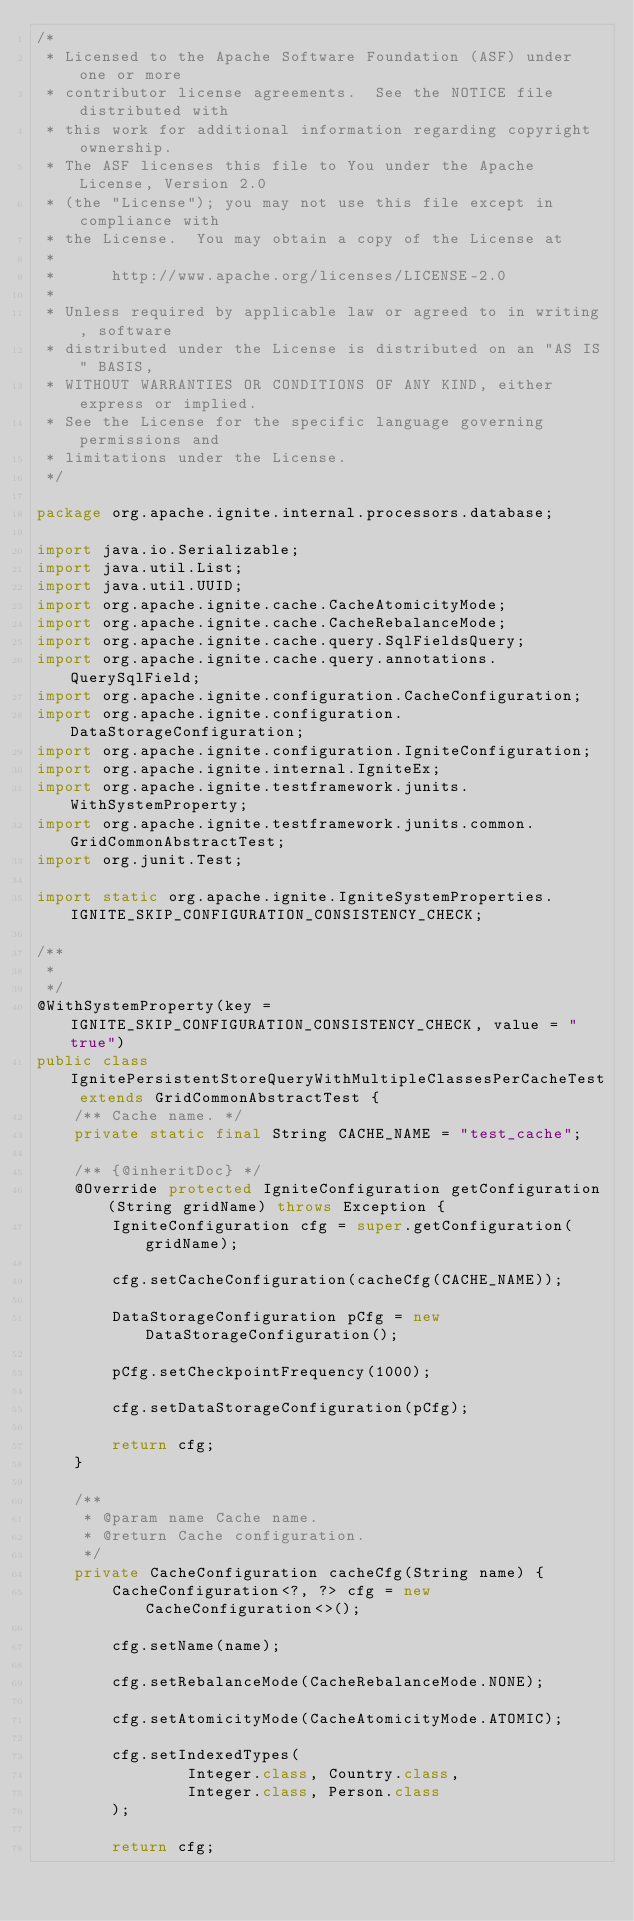Convert code to text. <code><loc_0><loc_0><loc_500><loc_500><_Java_>/*
 * Licensed to the Apache Software Foundation (ASF) under one or more
 * contributor license agreements.  See the NOTICE file distributed with
 * this work for additional information regarding copyright ownership.
 * The ASF licenses this file to You under the Apache License, Version 2.0
 * (the "License"); you may not use this file except in compliance with
 * the License.  You may obtain a copy of the License at
 *
 *      http://www.apache.org/licenses/LICENSE-2.0
 *
 * Unless required by applicable law or agreed to in writing, software
 * distributed under the License is distributed on an "AS IS" BASIS,
 * WITHOUT WARRANTIES OR CONDITIONS OF ANY KIND, either express or implied.
 * See the License for the specific language governing permissions and
 * limitations under the License.
 */

package org.apache.ignite.internal.processors.database;

import java.io.Serializable;
import java.util.List;
import java.util.UUID;
import org.apache.ignite.cache.CacheAtomicityMode;
import org.apache.ignite.cache.CacheRebalanceMode;
import org.apache.ignite.cache.query.SqlFieldsQuery;
import org.apache.ignite.cache.query.annotations.QuerySqlField;
import org.apache.ignite.configuration.CacheConfiguration;
import org.apache.ignite.configuration.DataStorageConfiguration;
import org.apache.ignite.configuration.IgniteConfiguration;
import org.apache.ignite.internal.IgniteEx;
import org.apache.ignite.testframework.junits.WithSystemProperty;
import org.apache.ignite.testframework.junits.common.GridCommonAbstractTest;
import org.junit.Test;

import static org.apache.ignite.IgniteSystemProperties.IGNITE_SKIP_CONFIGURATION_CONSISTENCY_CHECK;

/**
 *
 */
@WithSystemProperty(key = IGNITE_SKIP_CONFIGURATION_CONSISTENCY_CHECK, value = "true")
public class IgnitePersistentStoreQueryWithMultipleClassesPerCacheTest extends GridCommonAbstractTest {
    /** Cache name. */
    private static final String CACHE_NAME = "test_cache";

    /** {@inheritDoc} */
    @Override protected IgniteConfiguration getConfiguration(String gridName) throws Exception {
        IgniteConfiguration cfg = super.getConfiguration(gridName);

        cfg.setCacheConfiguration(cacheCfg(CACHE_NAME));

        DataStorageConfiguration pCfg = new DataStorageConfiguration();

        pCfg.setCheckpointFrequency(1000);

        cfg.setDataStorageConfiguration(pCfg);

        return cfg;
    }

    /**
     * @param name Cache name.
     * @return Cache configuration.
     */
    private CacheConfiguration cacheCfg(String name) {
        CacheConfiguration<?, ?> cfg = new CacheConfiguration<>();

        cfg.setName(name);

        cfg.setRebalanceMode(CacheRebalanceMode.NONE);

        cfg.setAtomicityMode(CacheAtomicityMode.ATOMIC);

        cfg.setIndexedTypes(
                Integer.class, Country.class,
                Integer.class, Person.class
        );

        return cfg;</code> 